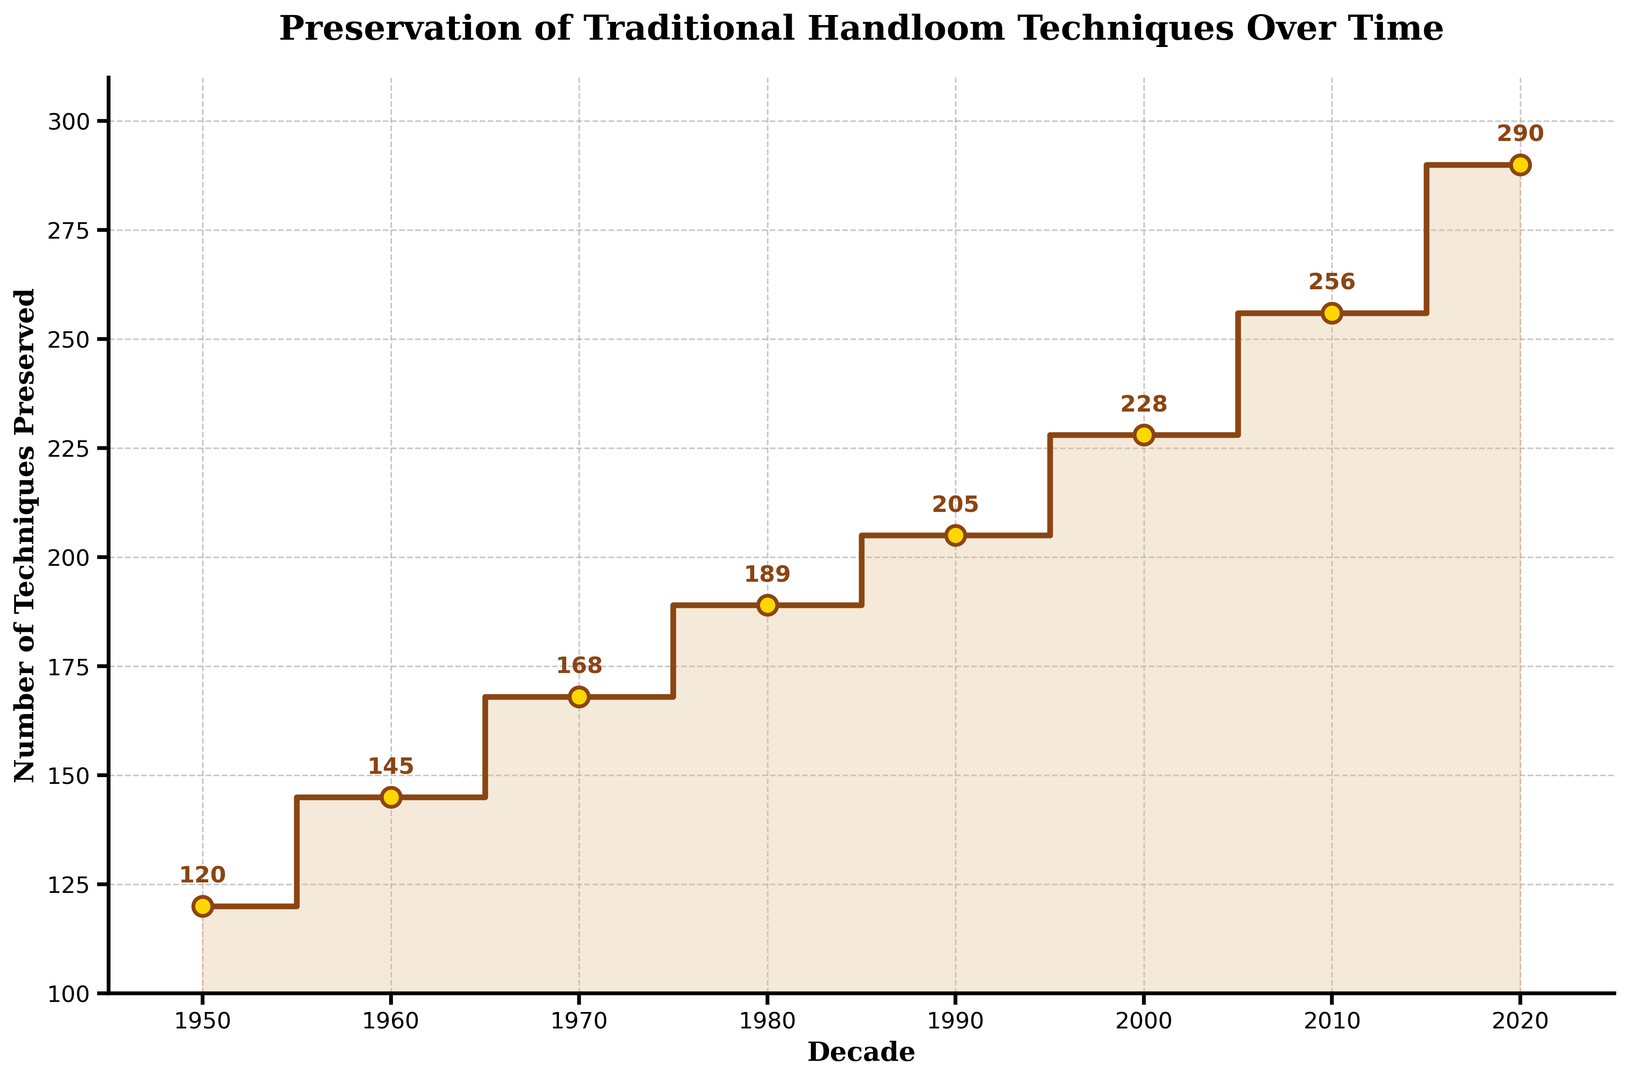What is the total number of techniques preserved from 1950 to 2020? To find the total number, add the number of techniques preserved for each decade: 120 + 145 + 168 + 189 + 205 + 228 + 256 + 290. The sum is 1601.
Answer: 1601 Which decade saw the smallest increase in the number of techniques preserved compared to the previous decade? Calculate the increase for each decade: 1960-1950 (25), 1970-1960 (23), 1980-1970 (21), 1990-1980 (16), 2000-1990 (23), 2010-2000 (28), 2020-2010 (34). The smallest increase occurred between 1980 and 1990, which is 16 techniques.
Answer: 1980-1990 How many more techniques were preserved in 2020 compared to 1950? Subtract the number of techniques preserved in 1950 from the number preserved in 2020: 290 - 120 = 170.
Answer: 170 What is the average number of techniques preserved per decade from 1950 to 2020? The total number of techniques from 1950 to 2020 is 1601. There are 8 decades, so the average is 1601 / 8 = 200.125.
Answer: 200.125 Which decade had the highest number of techniques preserved? The highest number of techniques preserved is 290 in the 2020 decade.
Answer: 2020 Is the growth in the number of techniques preserved consistent across decades? The growth varies across decades: 25 (1950-1960), 23 (1960-1970), 21 (1970-1980), 16 (1980-1990), 23 (1990-2000), 28 (2000-2010), 34 (2010-2020). Thus, it is not consistent.
Answer: No Compare the number of techniques preserved in 1980 and 2000. In 1980, 189 techniques were preserved and in 2000, 228 techniques were preserved. So, in 2000, 39 more techniques were preserved than in 1980.
Answer: 39 What is the visual effect of the plot's fill color between the steps? The fill color (light brown) visually emphasizes the area between the steps, highlighting the cumulative increase of techniques preserved over decades.
Answer: Highlighting cumulative increase What noticeable pattern do you observe in the preservation of handloom techniques over time? There is a general upward trend in the number of techniques preserved over each decade, suggesting sustained efforts in preserving traditional handloom crafts.
Answer: Upward trend 